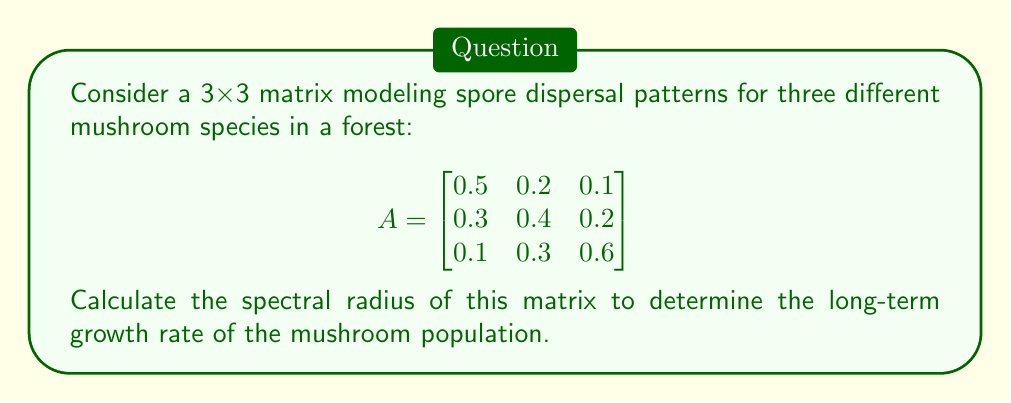Give your solution to this math problem. To find the spectral radius of matrix A, we need to follow these steps:

1) First, calculate the characteristic polynomial of A:
   $det(A - \lambda I) = 0$

   $$\begin{vmatrix}
   0.5-\lambda & 0.2 & 0.1 \\
   0.3 & 0.4-\lambda & 0.2 \\
   0.1 & 0.3 & 0.6-\lambda
   \end{vmatrix} = 0$$

2) Expand the determinant:
   $(0.5-\lambda)[(0.4-\lambda)(0.6-\lambda) - 0.06] - 0.2[0.3(0.6-\lambda) - 0.02] + 0.1[0.3(0.4-\lambda) - 0.06] = 0$

3) Simplify:
   $-\lambda^3 + 1.5\lambda^2 - 0.61\lambda + 0.076 = 0$

4) Solve this cubic equation. The roots are the eigenvalues of A. Using a numerical method or a calculator, we get:
   $\lambda_1 \approx 0.9053$
   $\lambda_2 \approx 0.3973$
   $\lambda_3 \approx 0.1974$

5) The spectral radius is the largest absolute value among these eigenvalues:
   $\rho(A) = \max(|\lambda_1|, |\lambda_2|, |\lambda_3|) = |\lambda_1| \approx 0.9053$

This value represents the long-term growth rate of the mushroom population based on the spore dispersal patterns.
Answer: $0.9053$ 